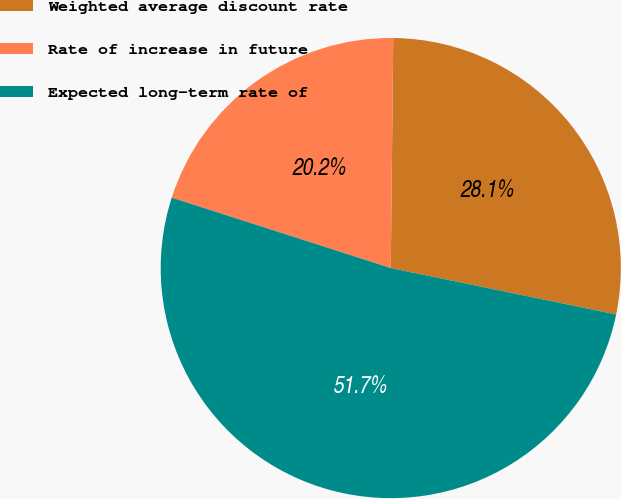Convert chart. <chart><loc_0><loc_0><loc_500><loc_500><pie_chart><fcel>Weighted average discount rate<fcel>Rate of increase in future<fcel>Expected long-term rate of<nl><fcel>28.06%<fcel>20.22%<fcel>51.71%<nl></chart> 